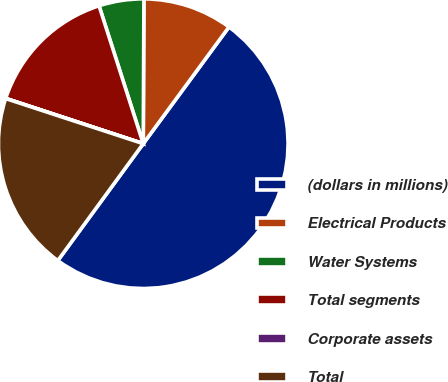Convert chart to OTSL. <chart><loc_0><loc_0><loc_500><loc_500><pie_chart><fcel>(dollars in millions)<fcel>Electrical Products<fcel>Water Systems<fcel>Total segments<fcel>Corporate assets<fcel>Total<nl><fcel>49.96%<fcel>10.01%<fcel>5.01%<fcel>15.0%<fcel>0.02%<fcel>20.0%<nl></chart> 